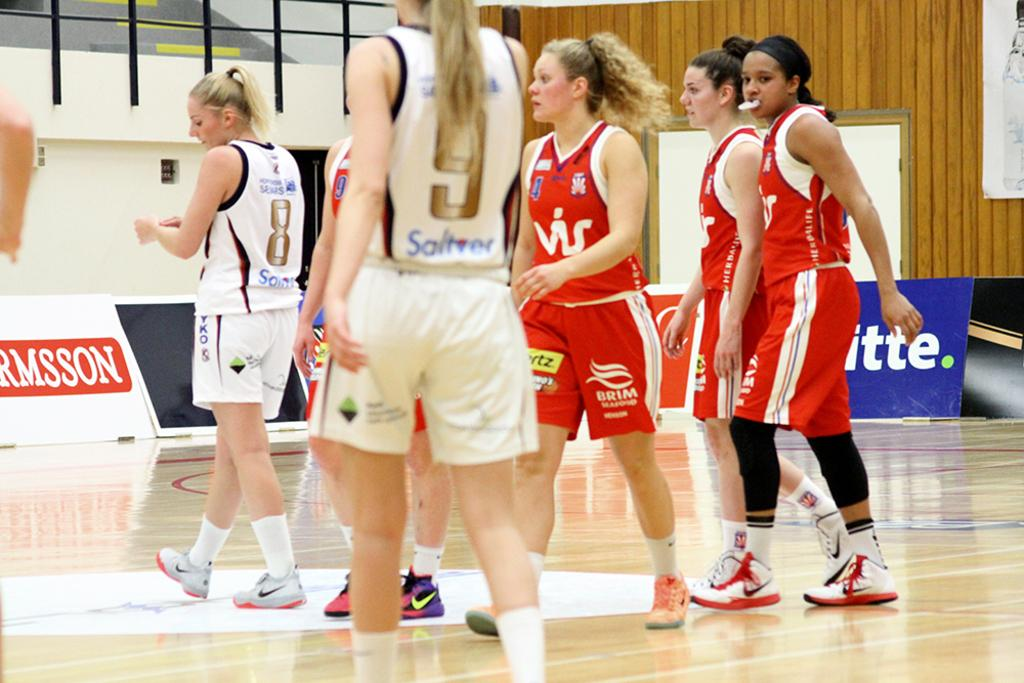<image>
Present a compact description of the photo's key features. A bunch of women playing an indoor sport; one of them is wearing a number 8 shirt. 